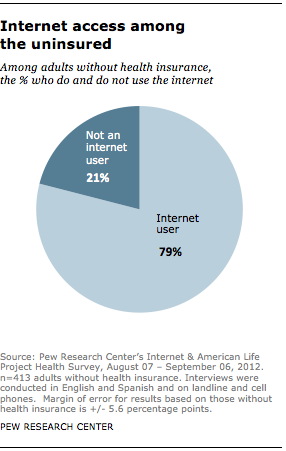Specify some key components in this picture. According to a recent survey, approximately 21% of adults without health insurance do not use the internet. The product of the smallest segment multiplied by 3 is less than the largest segment, and this result does not meet the criteria. 